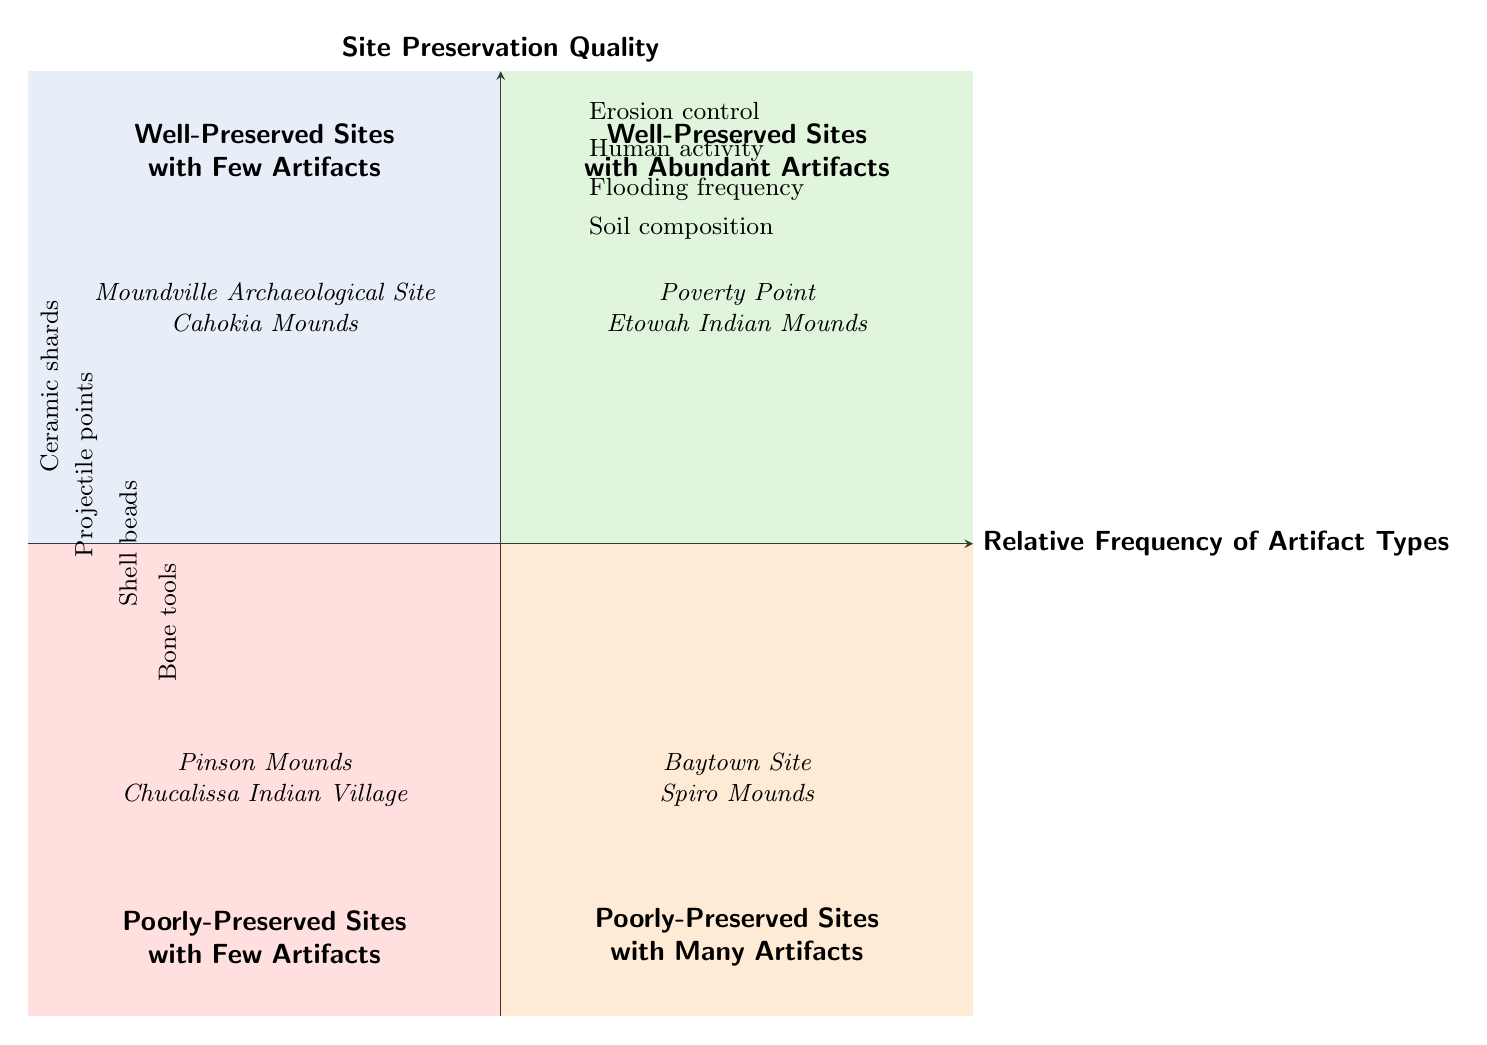What quadrant contains Poverty Point? Poverty Point is listed in the examples of the "Well-Preserved Sites with Abundant Artifacts" quadrant. Therefore, it is located in the upper right quadrant of the chart.
Answer: Well-Preserved Sites with Abundant Artifacts How many artifact types are listed in the diagram? There are four artifact types mentioned: Ceramic shards, Projectile points, Shell beads, and Bone tools. Their total count is four.
Answer: 4 What is the title of the quadrant for poorly-preserved sites with many artifacts? The title for this quadrant is clearly labeled in the diagram as "Poorly-Preserved Sites with Many Artifacts." Hence, this is the answer to the question.
Answer: Poorly-Preserved Sites with Many Artifacts Which two sites are examples of poorly-preserved sites with few artifacts? The examples provided in the "Poorly-Preserved Sites with Few Artifacts" quadrant are Pinson Mounds and Chucalissa Indian Village, as indicated in the lower left section of the chart.
Answer: Pinson Mounds, Chucalissa Indian Village What artifact type is situated closest to the y-axis? The artifact type listed closest to the y-axis is "Ceramic shards," which is indicated in the left side of the diagram.
Answer: Ceramic shards Which two preservation factors are noted for potential impact in the diagram? The chart provides four preservation factors, but two notable ones are "Erosion control" and "Human activity," which are situated towards the top of the chart near the y-axis.
Answer: Erosion control, Human activity What quadrant contains the Moundville Archaeological Site? Moundville Archaeological Site is an example listed in the quadrant titled "Well-Preserved Sites with Few Artifacts." Therefore, it resides in the upper left quadrant of the chart.
Answer: Well-Preserved Sites with Few Artifacts Are there any artifact types associated with poorly-preserved sites? Yes, all the artifact types are relevant to both quadrants involving poorly-preserved sites. Specifically, they are only displayed in the sections for "Poorly-Preserved Sites with Many Artifacts" and "Poorly-Preserved Sites with Few Artifacts."
Answer: Yes How many quadrants are present in this diagram? The diagram is divided into four distinct quadrants, each representing a different combination of relative frequency of artifact types and site preservation quality.
Answer: 4 